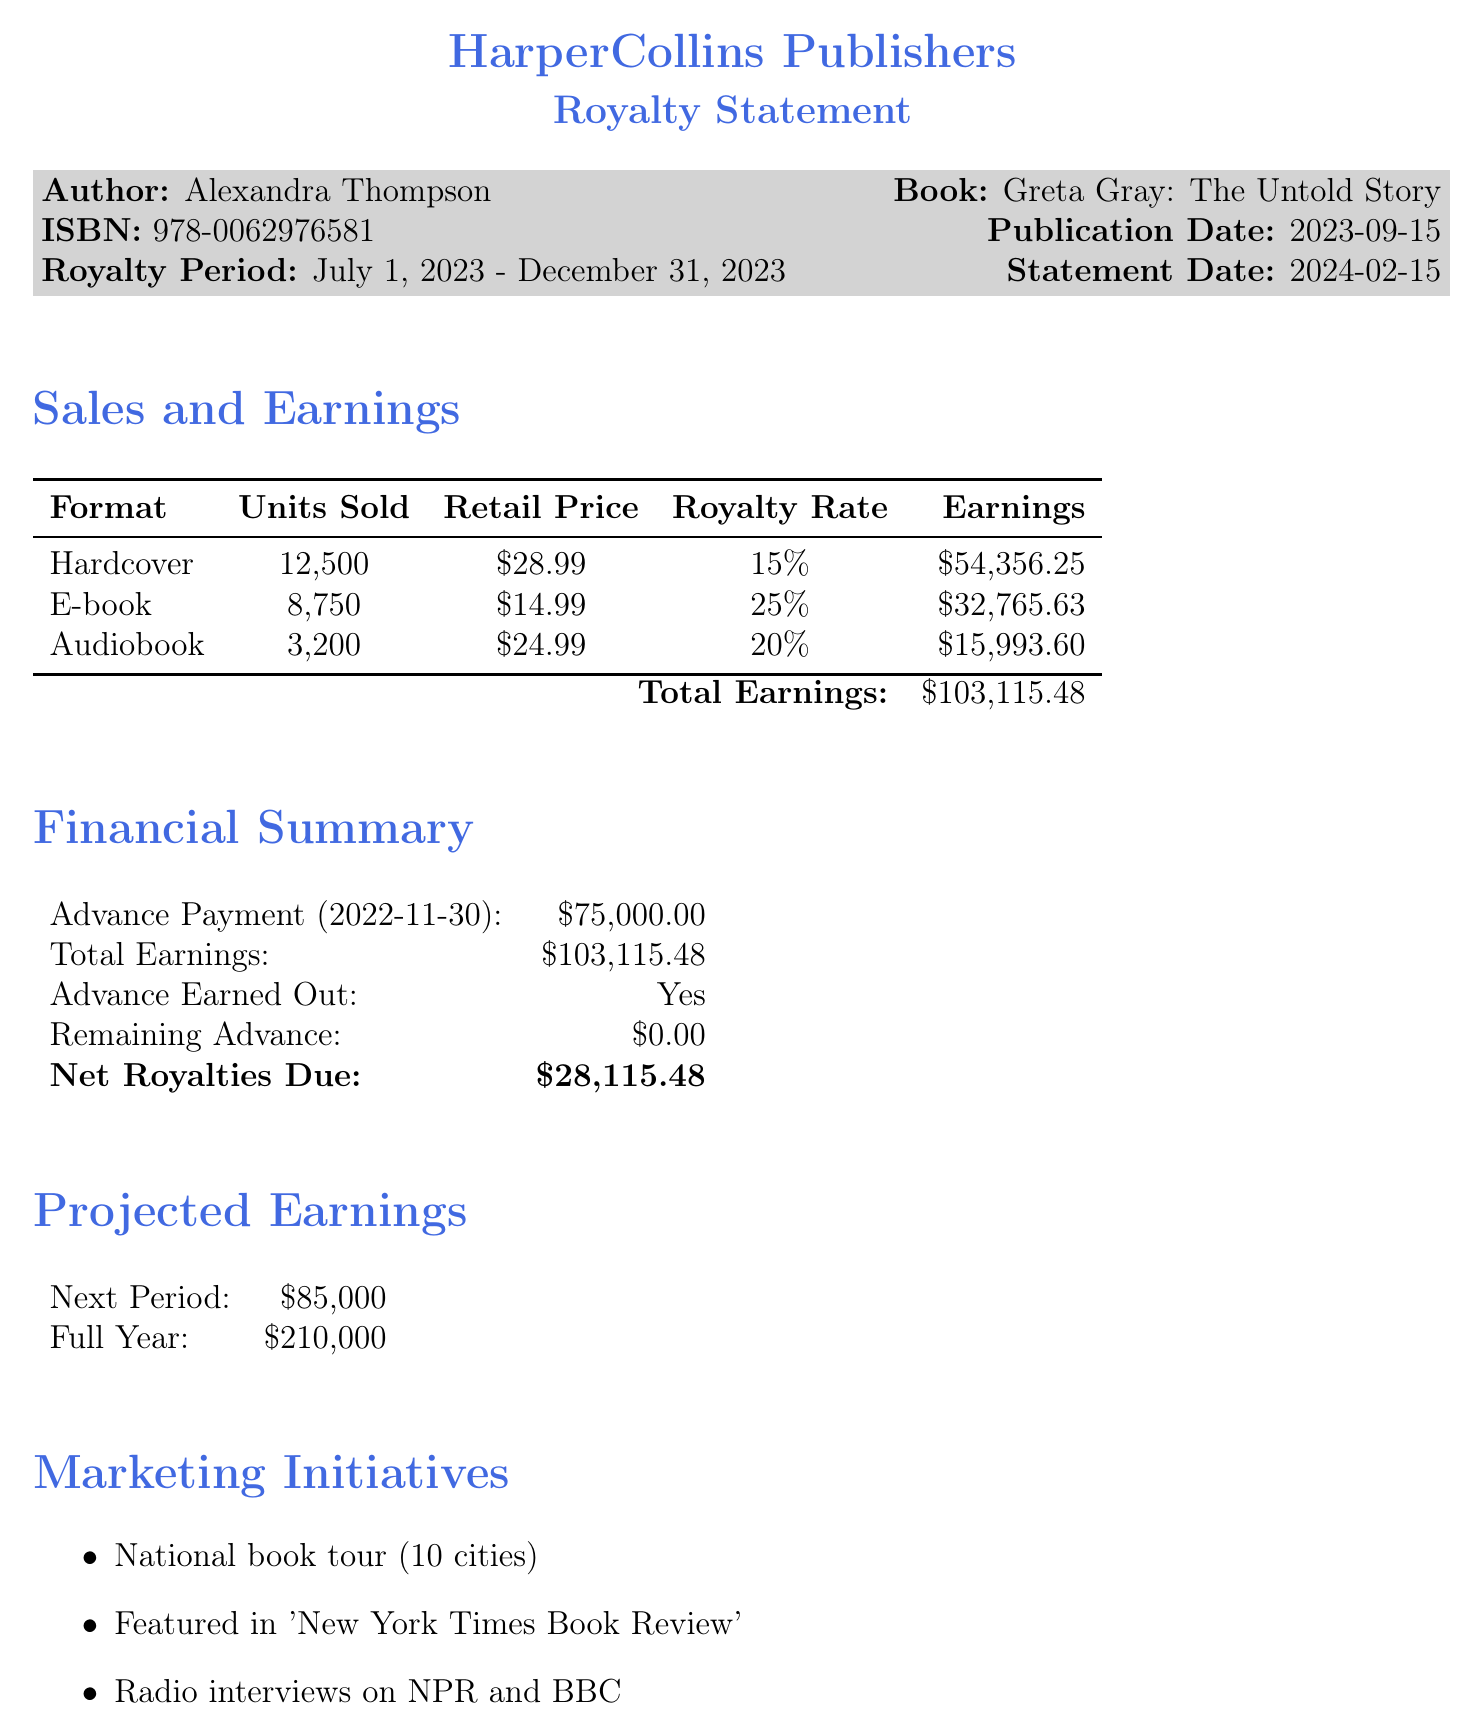What is the total earnings? The total earnings are listed at the bottom of the sales and earnings section, which summarizes all earnings from various formats.
Answer: $103,115.48 Who is the author? The document states the author's name at the beginning of the royalty statement, under the publisher's information.
Answer: Alexandra Thompson What is the advance payment amount? The advance payment amount is detailed in the financial summary section of the document.
Answer: $75,000.00 What is the publication date of the book? The publication date is explicitly stated in the royalty statement section, alongside the ISBN and other details.
Answer: 2023-09-15 How many units of hardcover were sold? The document lists the sales figures for hardcover in the sales and earnings section.
Answer: 12,500 What is the net royalties due? The net royalties due are indicated in the financial summary section as the amount remaining after the advance has been earned out.
Answer: $28,115.48 What are the projected earnings for the next period? The projected earnings for the next period are found in the projected earnings section of the document.
Answer: $85,000 Name one marketing initiative mentioned. The marketing initiatives are listed under their specific section, showcasing various promotional activities planned for the book.
Answer: National book tour (10 cities) Is the advance earned out? The financial summary section clearly states whether the advance has been earned out.
Answer: Yes 